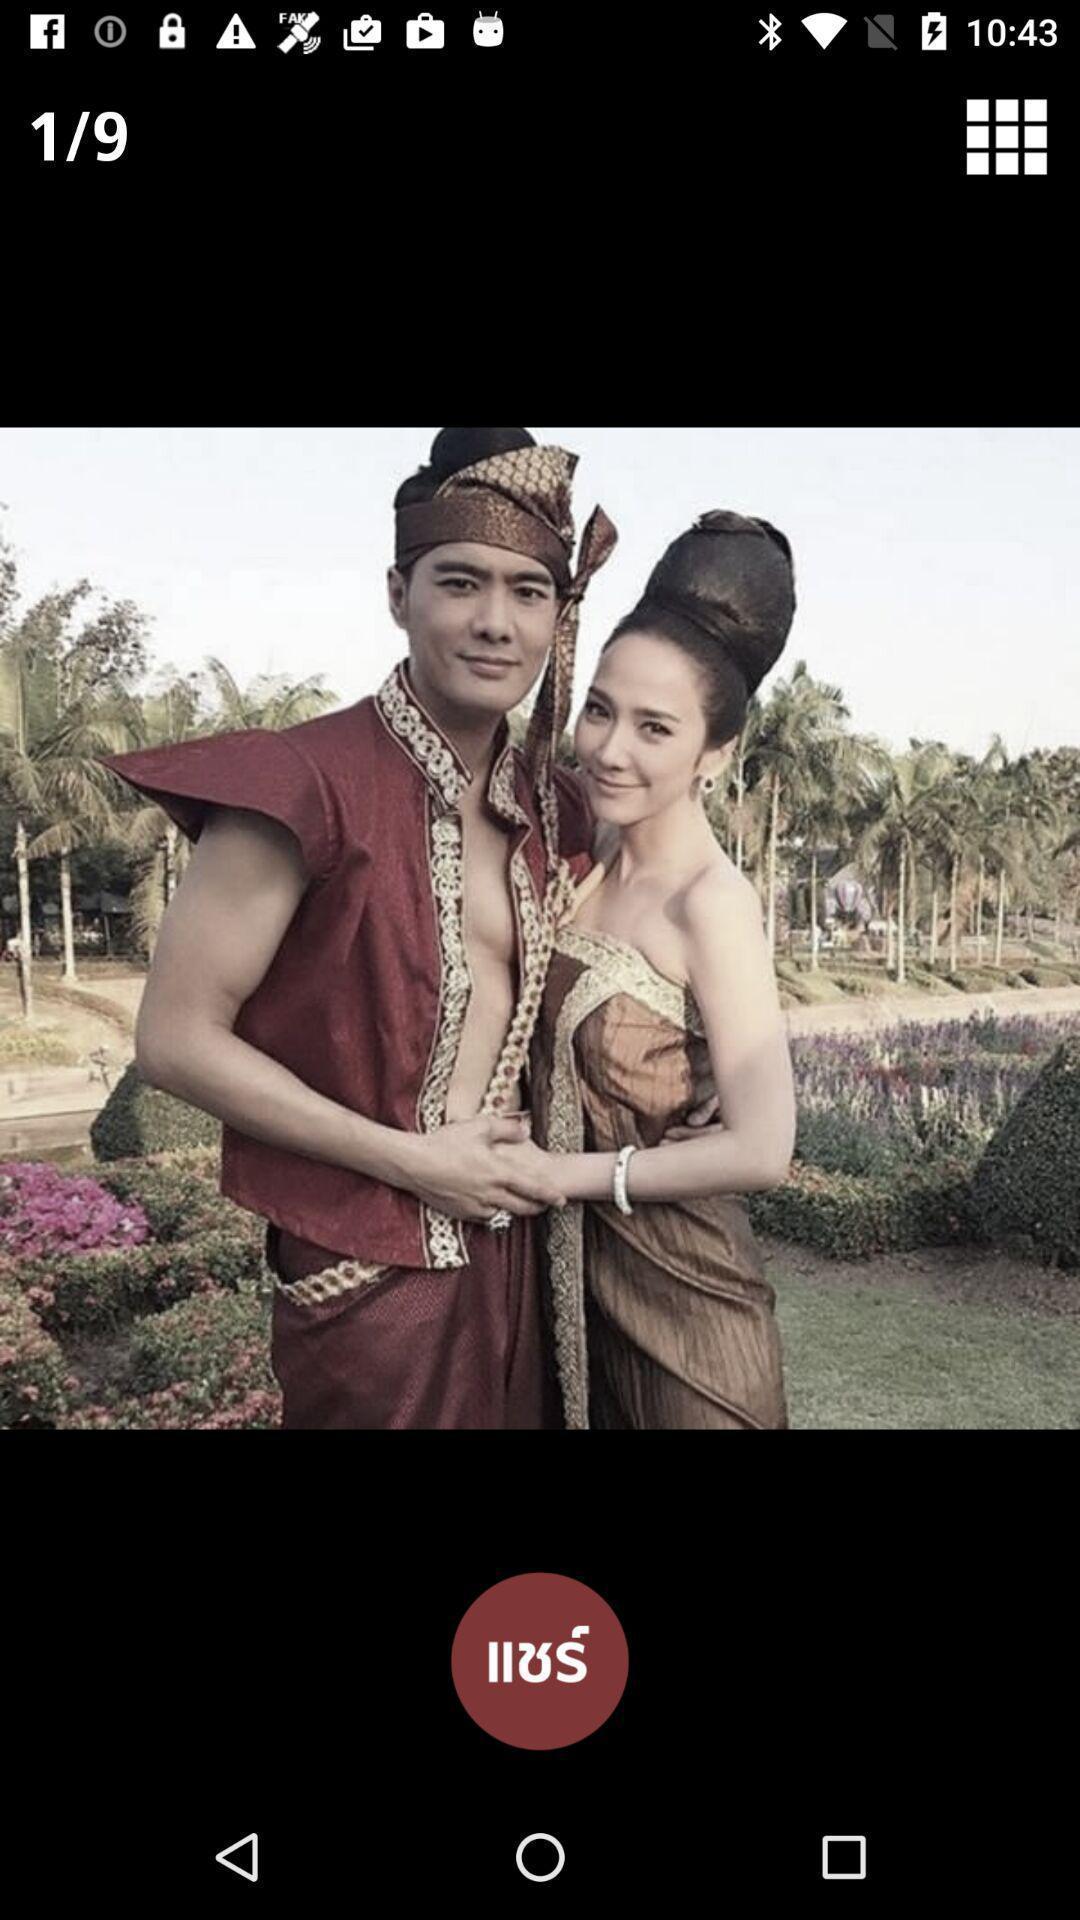Summarize the main components in this picture. Screen page showing an image. 